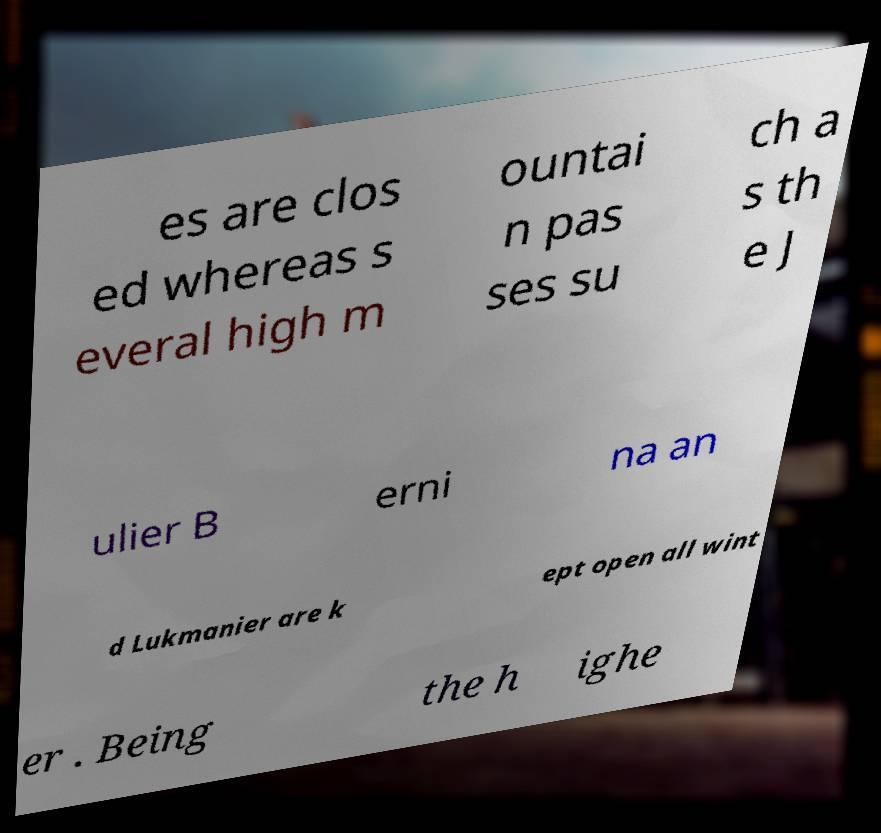Can you accurately transcribe the text from the provided image for me? es are clos ed whereas s everal high m ountai n pas ses su ch a s th e J ulier B erni na an d Lukmanier are k ept open all wint er . Being the h ighe 